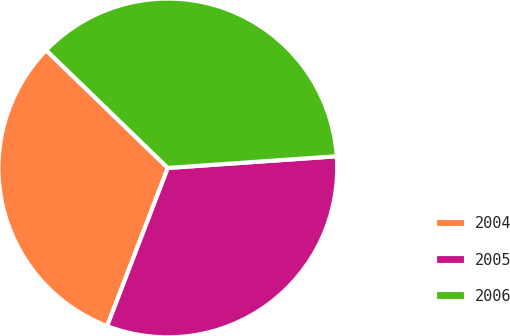Convert chart to OTSL. <chart><loc_0><loc_0><loc_500><loc_500><pie_chart><fcel>2004<fcel>2005<fcel>2006<nl><fcel>31.41%<fcel>31.93%<fcel>36.66%<nl></chart> 